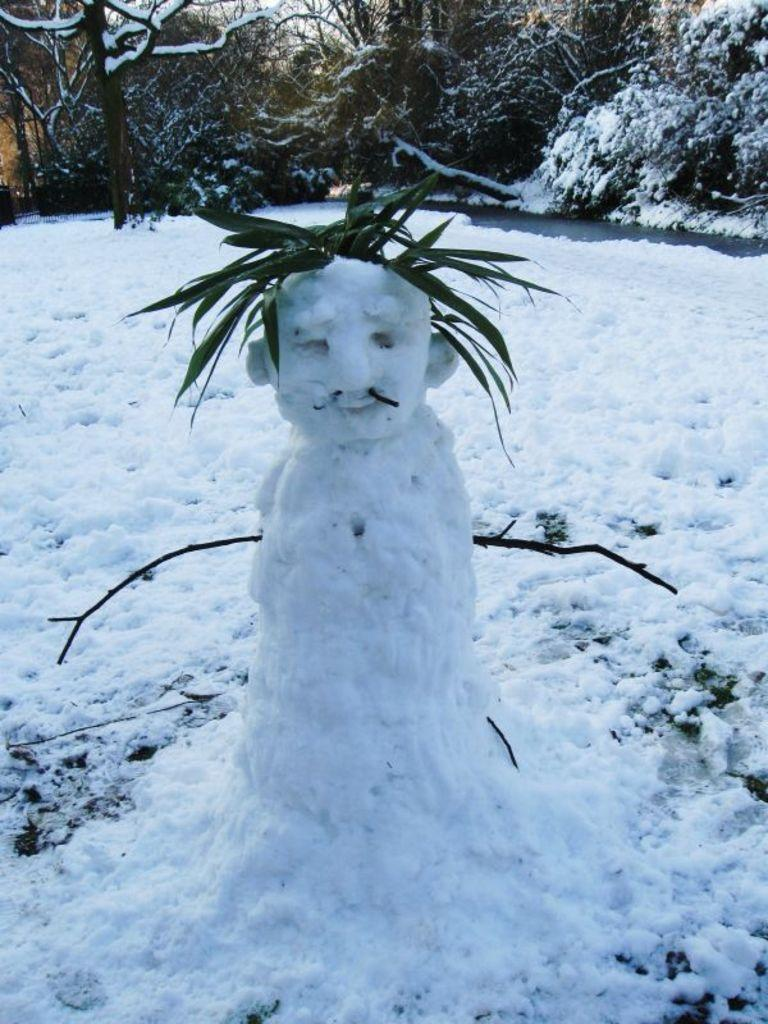What is the main subject of the image? There is an object made with snow in the image. What is attached to or associated with the snow object? There are leaves associated with the snow object. What type of natural environment can be seen in the image? There are trees visible in the image. What type of weather is depicted in the image? There is snow visible in the image. What type of garden can be seen in the image? There is no garden present in the image; it features a snow object with leaves and trees in the background. Can you tell me how many bikes are parked near the snow object in the image? There are no bikes present in the image. 